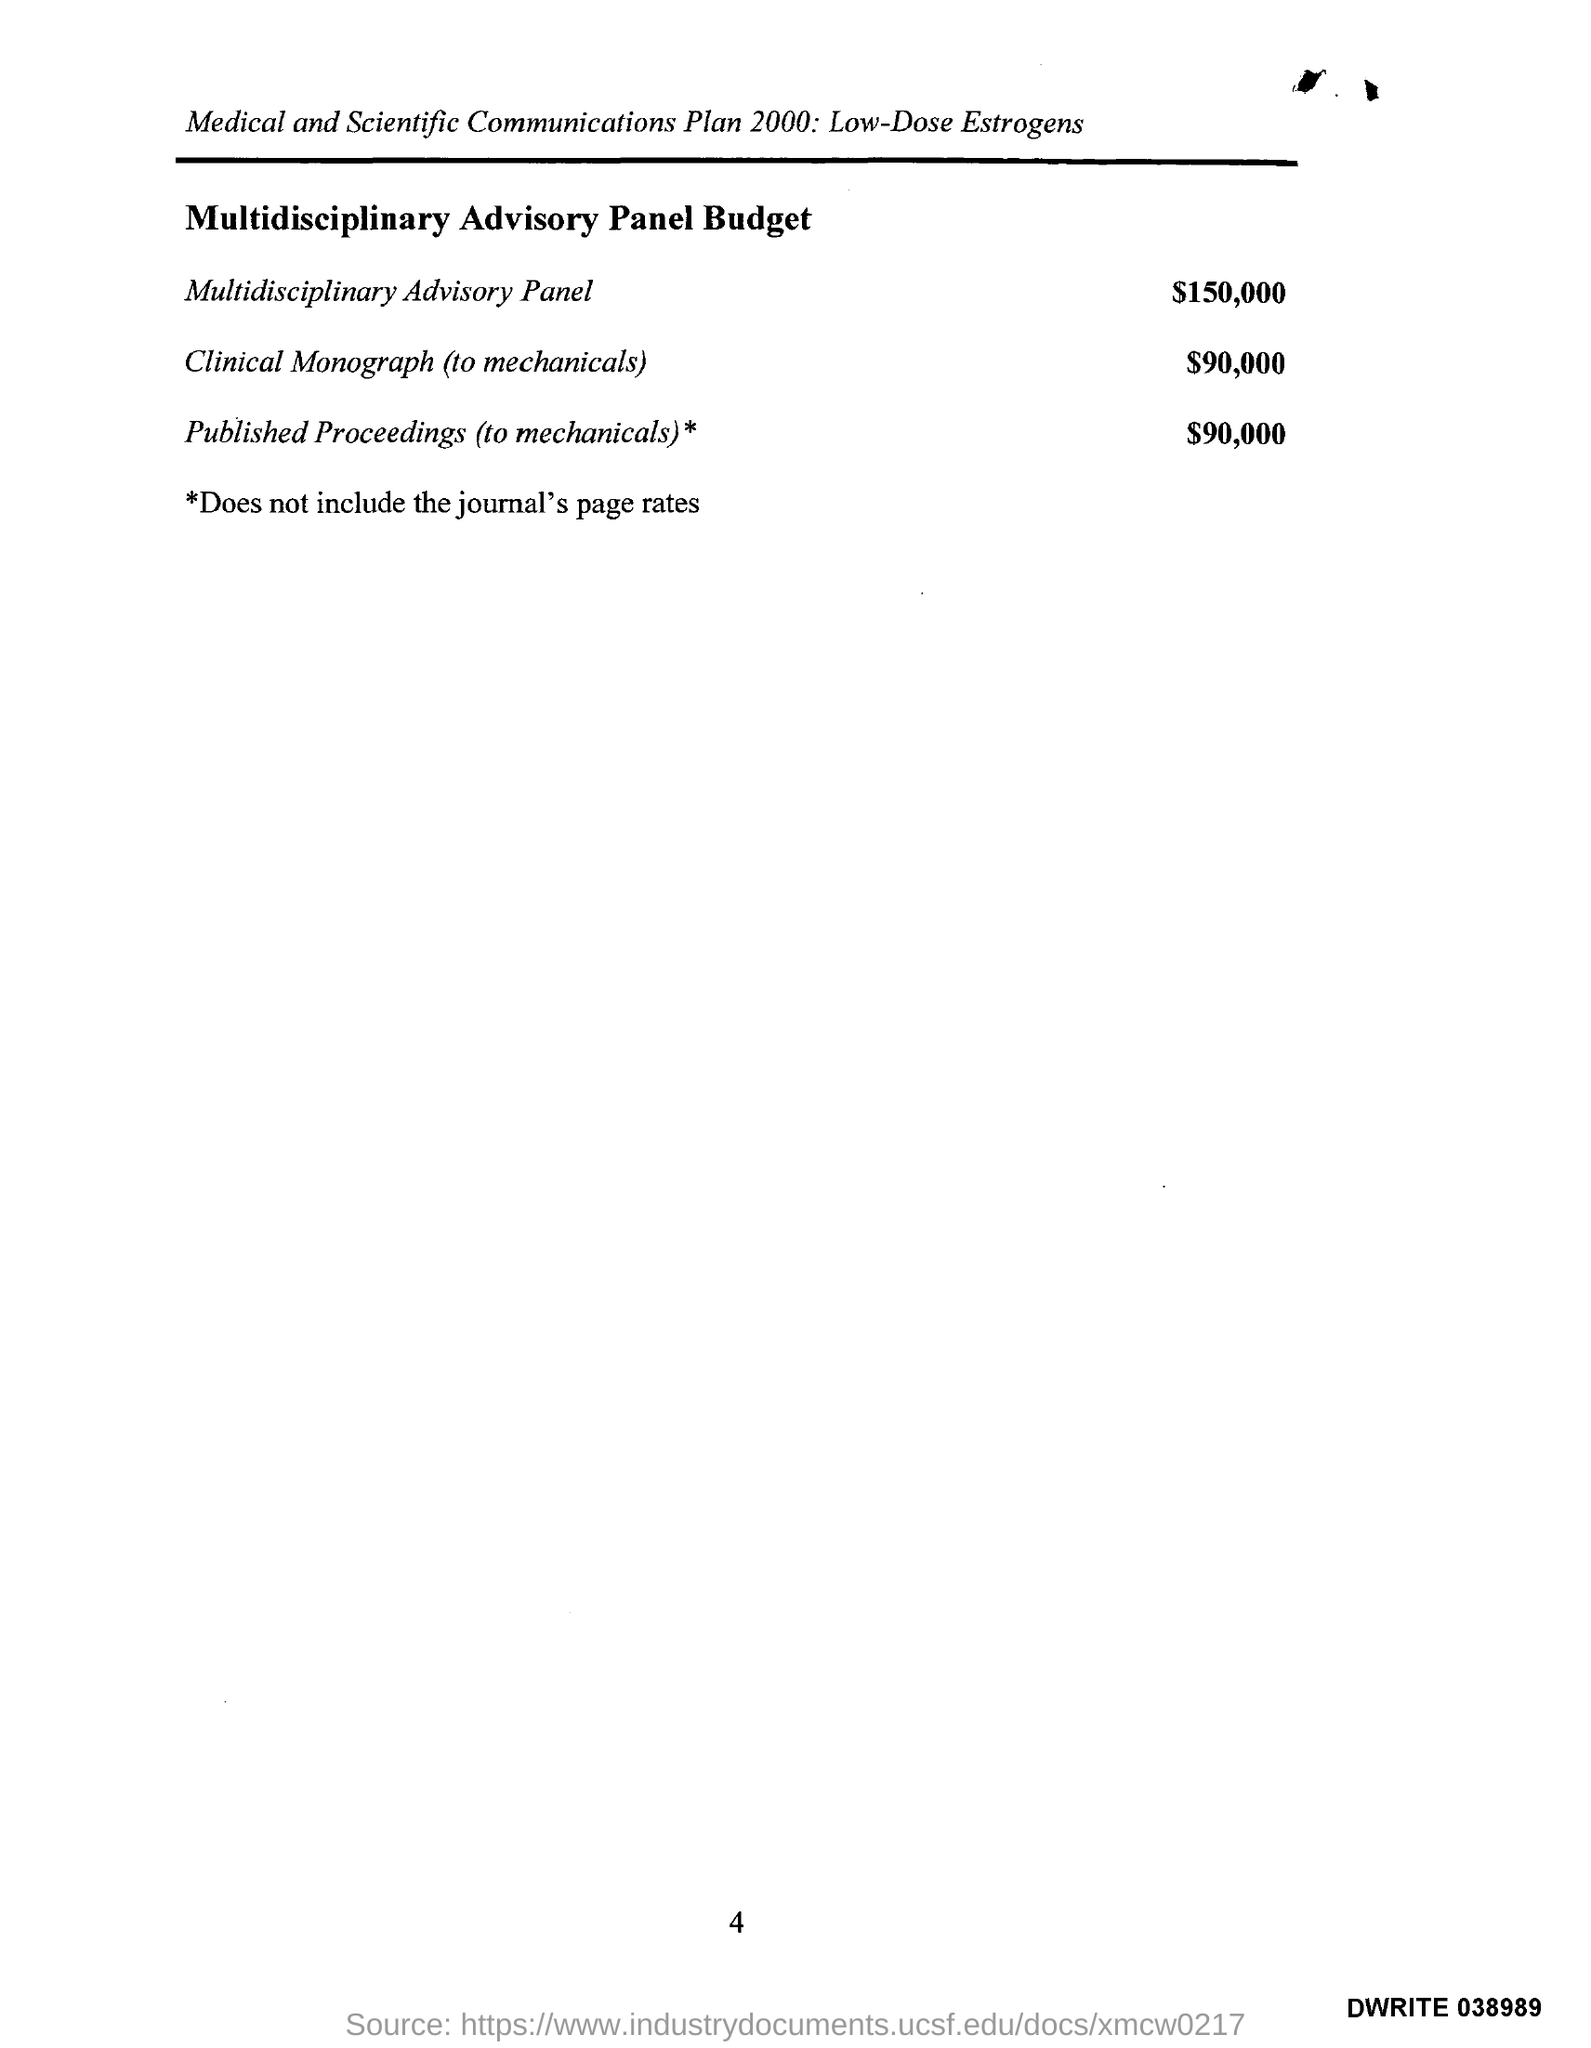Outline some significant characteristics in this image. The cost of a multidisciplinary advisory panel is approximately $150,000. 